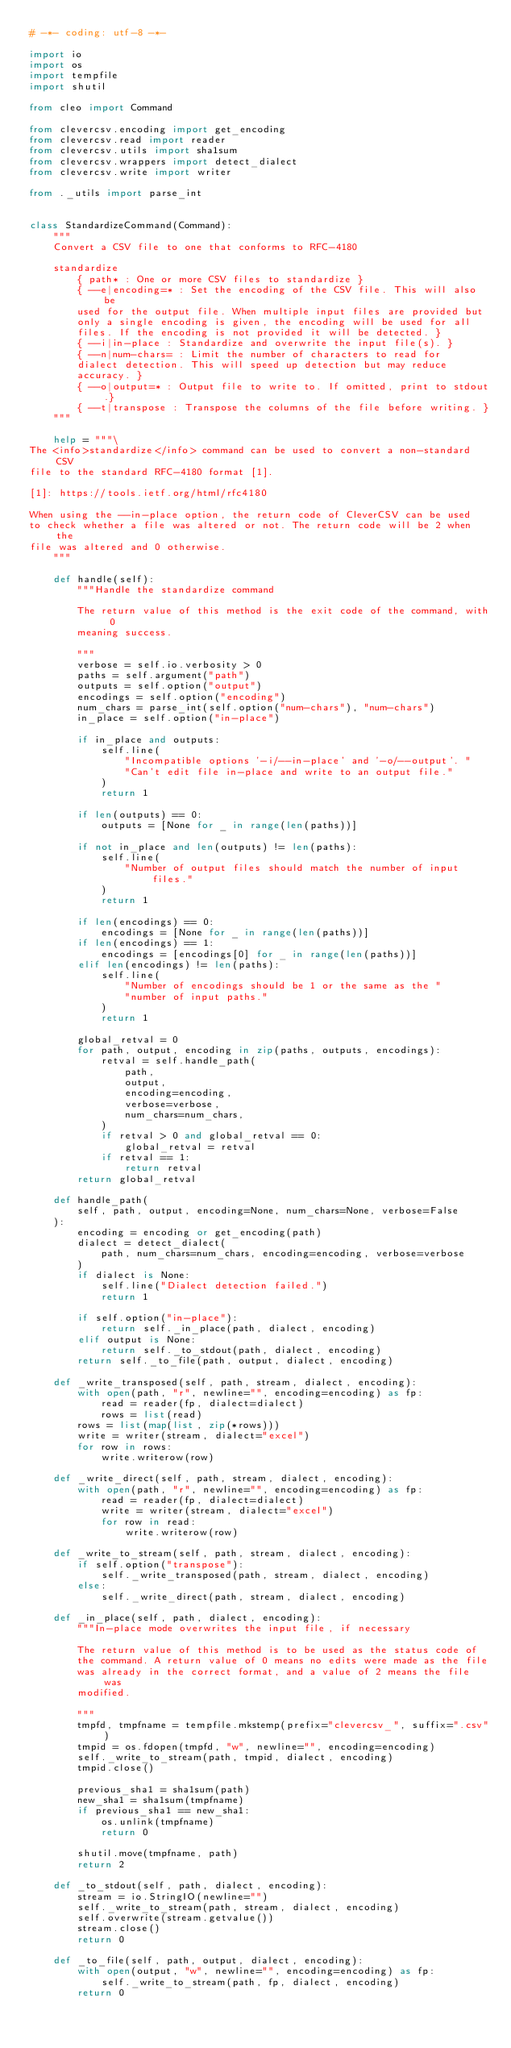<code> <loc_0><loc_0><loc_500><loc_500><_Python_># -*- coding: utf-8 -*-

import io
import os
import tempfile
import shutil

from cleo import Command

from clevercsv.encoding import get_encoding
from clevercsv.read import reader
from clevercsv.utils import sha1sum
from clevercsv.wrappers import detect_dialect
from clevercsv.write import writer

from ._utils import parse_int


class StandardizeCommand(Command):
    """
    Convert a CSV file to one that conforms to RFC-4180

    standardize
        { path* : One or more CSV files to standardize }
        { --e|encoding=* : Set the encoding of the CSV file. This will also be
        used for the output file. When multiple input files are provided but
        only a single encoding is given, the encoding will be used for all
        files. If the encoding is not provided it will be detected. }
        { --i|in-place : Standardize and overwrite the input file(s). }
        { --n|num-chars= : Limit the number of characters to read for
        dialect detection. This will speed up detection but may reduce
        accuracy. }
        { --o|output=* : Output file to write to. If omitted, print to stdout.}
        { --t|transpose : Transpose the columns of the file before writing. }
    """

    help = """\
The <info>standardize</info> command can be used to convert a non-standard CSV 
file to the standard RFC-4180 format [1].

[1]: https://tools.ietf.org/html/rfc4180

When using the --in-place option, the return code of CleverCSV can be used
to check whether a file was altered or not. The return code will be 2 when the 
file was altered and 0 otherwise.
    """

    def handle(self):
        """Handle the standardize command

        The return value of this method is the exit code of the command, with 0
        meaning success.

        """
        verbose = self.io.verbosity > 0
        paths = self.argument("path")
        outputs = self.option("output")
        encodings = self.option("encoding")
        num_chars = parse_int(self.option("num-chars"), "num-chars")
        in_place = self.option("in-place")

        if in_place and outputs:
            self.line(
                "Incompatible options '-i/--in-place' and '-o/--output'. "
                "Can't edit file in-place and write to an output file."
            )
            return 1

        if len(outputs) == 0:
            outputs = [None for _ in range(len(paths))]

        if not in_place and len(outputs) != len(paths):
            self.line(
                "Number of output files should match the number of input files."
            )
            return 1

        if len(encodings) == 0:
            encodings = [None for _ in range(len(paths))]
        if len(encodings) == 1:
            encodings = [encodings[0] for _ in range(len(paths))]
        elif len(encodings) != len(paths):
            self.line(
                "Number of encodings should be 1 or the same as the "
                "number of input paths."
            )
            return 1

        global_retval = 0
        for path, output, encoding in zip(paths, outputs, encodings):
            retval = self.handle_path(
                path,
                output,
                encoding=encoding,
                verbose=verbose,
                num_chars=num_chars,
            )
            if retval > 0 and global_retval == 0:
                global_retval = retval
            if retval == 1:
                return retval
        return global_retval

    def handle_path(
        self, path, output, encoding=None, num_chars=None, verbose=False
    ):
        encoding = encoding or get_encoding(path)
        dialect = detect_dialect(
            path, num_chars=num_chars, encoding=encoding, verbose=verbose
        )
        if dialect is None:
            self.line("Dialect detection failed.")
            return 1

        if self.option("in-place"):
            return self._in_place(path, dialect, encoding)
        elif output is None:
            return self._to_stdout(path, dialect, encoding)
        return self._to_file(path, output, dialect, encoding)

    def _write_transposed(self, path, stream, dialect, encoding):
        with open(path, "r", newline="", encoding=encoding) as fp:
            read = reader(fp, dialect=dialect)
            rows = list(read)
        rows = list(map(list, zip(*rows)))
        write = writer(stream, dialect="excel")
        for row in rows:
            write.writerow(row)

    def _write_direct(self, path, stream, dialect, encoding):
        with open(path, "r", newline="", encoding=encoding) as fp:
            read = reader(fp, dialect=dialect)
            write = writer(stream, dialect="excel")
            for row in read:
                write.writerow(row)

    def _write_to_stream(self, path, stream, dialect, encoding):
        if self.option("transpose"):
            self._write_transposed(path, stream, dialect, encoding)
        else:
            self._write_direct(path, stream, dialect, encoding)

    def _in_place(self, path, dialect, encoding):
        """In-place mode overwrites the input file, if necessary

        The return value of this method is to be used as the status code of
        the command. A return value of 0 means no edits were made as the file
        was already in the correct format, and a value of 2 means the file was
        modified.

        """
        tmpfd, tmpfname = tempfile.mkstemp(prefix="clevercsv_", suffix=".csv")
        tmpid = os.fdopen(tmpfd, "w", newline="", encoding=encoding)
        self._write_to_stream(path, tmpid, dialect, encoding)
        tmpid.close()

        previous_sha1 = sha1sum(path)
        new_sha1 = sha1sum(tmpfname)
        if previous_sha1 == new_sha1:
            os.unlink(tmpfname)
            return 0

        shutil.move(tmpfname, path)
        return 2

    def _to_stdout(self, path, dialect, encoding):
        stream = io.StringIO(newline="")
        self._write_to_stream(path, stream, dialect, encoding)
        self.overwrite(stream.getvalue())
        stream.close()
        return 0

    def _to_file(self, path, output, dialect, encoding):
        with open(output, "w", newline="", encoding=encoding) as fp:
            self._write_to_stream(path, fp, dialect, encoding)
        return 0
</code> 